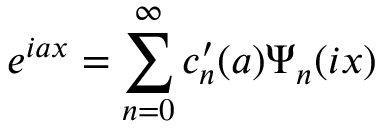<formula> <loc_0><loc_0><loc_500><loc_500>e ^ { i a x } = \sum _ { n = 0 } ^ { \infty } c _ { n } ^ { \prime } ( a ) \Psi _ { n } ( i x )</formula> 